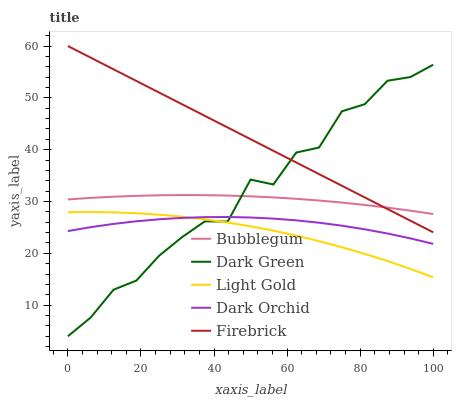Does Light Gold have the minimum area under the curve?
Answer yes or no. Yes. Does Firebrick have the maximum area under the curve?
Answer yes or no. Yes. Does Dark Orchid have the minimum area under the curve?
Answer yes or no. No. Does Dark Orchid have the maximum area under the curve?
Answer yes or no. No. Is Firebrick the smoothest?
Answer yes or no. Yes. Is Dark Green the roughest?
Answer yes or no. Yes. Is Light Gold the smoothest?
Answer yes or no. No. Is Light Gold the roughest?
Answer yes or no. No. Does Dark Green have the lowest value?
Answer yes or no. Yes. Does Light Gold have the lowest value?
Answer yes or no. No. Does Firebrick have the highest value?
Answer yes or no. Yes. Does Light Gold have the highest value?
Answer yes or no. No. Is Light Gold less than Bubblegum?
Answer yes or no. Yes. Is Bubblegum greater than Dark Orchid?
Answer yes or no. Yes. Does Dark Green intersect Light Gold?
Answer yes or no. Yes. Is Dark Green less than Light Gold?
Answer yes or no. No. Is Dark Green greater than Light Gold?
Answer yes or no. No. Does Light Gold intersect Bubblegum?
Answer yes or no. No. 